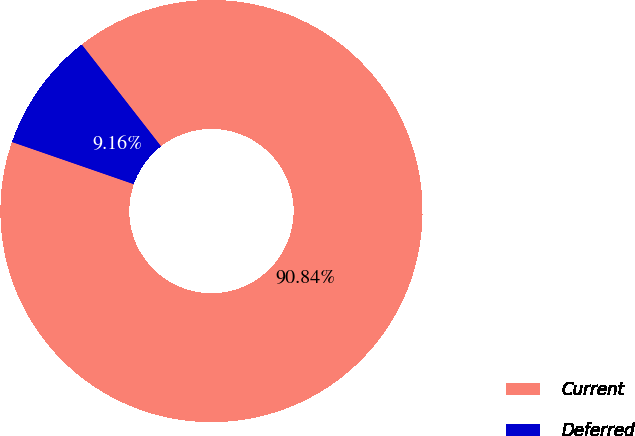Convert chart. <chart><loc_0><loc_0><loc_500><loc_500><pie_chart><fcel>Current<fcel>Deferred<nl><fcel>90.84%<fcel>9.16%<nl></chart> 